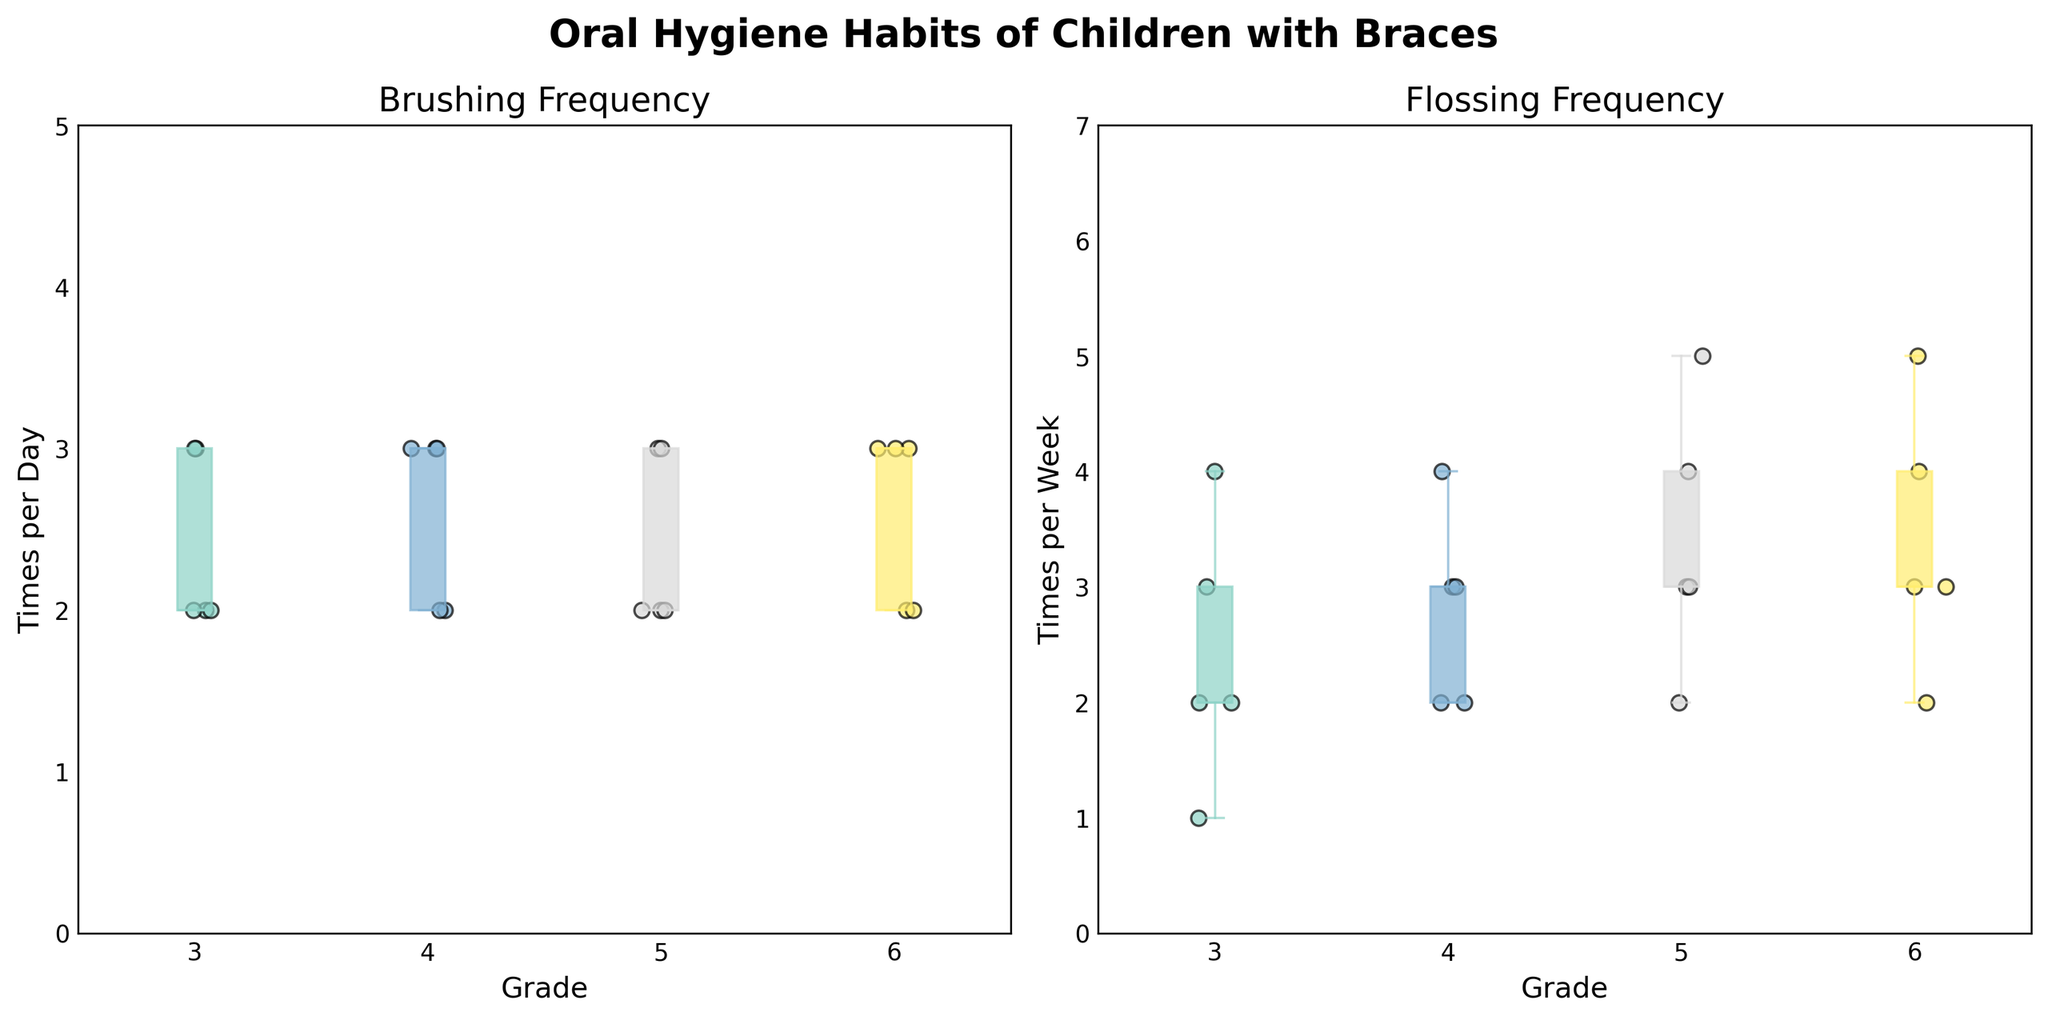What is the title of the figure? The title is located at the top of the figure and it reads "Oral Hygiene Habits of Children with Braces."
Answer: Oral Hygiene Habits of Children with Braces What are the x-axis labels in the plots? The x-axis labels, positioned below the horizontal lines in both plots, represent the different grades: 3, 4, 5, and 6.
Answer: 3, 4, 5, 6 How many times per day does the median child in 3rd grade brush their teeth? The median line inside the box of the 3rd-grade brushing frequency box plot indicates the median value, which is 2.
Answer: 2 What is the highest frequency of flossing per week for 5th graders? The upper edge of the whisker extends to the maximum value in the 5th-grade flossing frequency box plot, which is 5.
Answer: 5 Which grade shows the highest median frequency of brushing per day? Compare the median lines across the brushing frequency box plots; the 4th and 6th grades share the highest median frequency, which is 3.
Answer: 4 and 6 Which grade has the most variation in the frequency of flossing per week? The grade with the largest interquartile range (box width) in the flossing frequency box plot has the most variation. The range for 5th grade is the widest.
Answer: 5 Are there any outliers in the 6th grade brushing frequency data? Outliers in a box plot are typically represented by points outside the whiskers; there are no such points in the 6th grade brushing frequency plot.
Answer: No If a child in 3rd grade brushes 2 times per day and flosses 2 times per week, how common is this habit based on the plots? The scatter points on the plots show how many children fall into this category. The plots indicate that this brushing and flossing routine is fairly common in 3rd grade.
Answer: Fairly common What is the range of brushing frequencies observed in 4th grade? The range is the difference between the maximum and minimum values in the box plot. For 4th grade brushing, the lowest value is 2 and the highest is 3, giving a range of 1.
Answer: 1 Which grade shows the most consistent brushing habits, and how can you tell? Consistency can be determined by the differences between the whiskers and the size of the interquartile range. Grade 4 has the smallest range and closely grouped data points, indicating the most consistent habits.
Answer: 4 